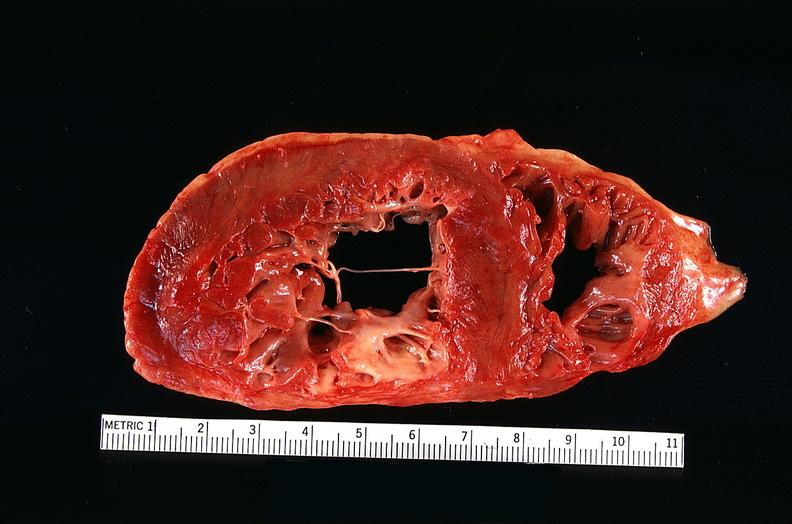s fibrinous peritonitis present?
Answer the question using a single word or phrase. No 